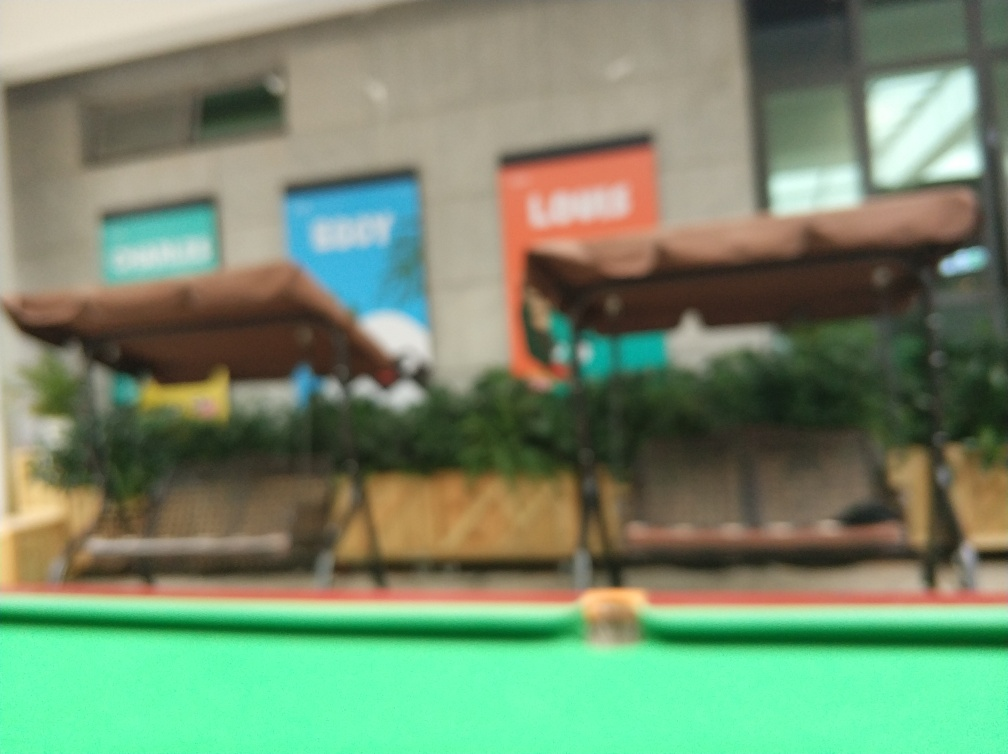Does the overall image appear blurry? Indeed, the image is notably blurry, making it difficult to discern fine details. This lack of sharpness could result from a camera's focus issue, motion during the exposure, or a low-quality lens. It impacts the viewer's ability to fully appreciate the scene depicted, which seems to be a public space, possibly an outdoor seating area with greenery and storefronts in the background. 